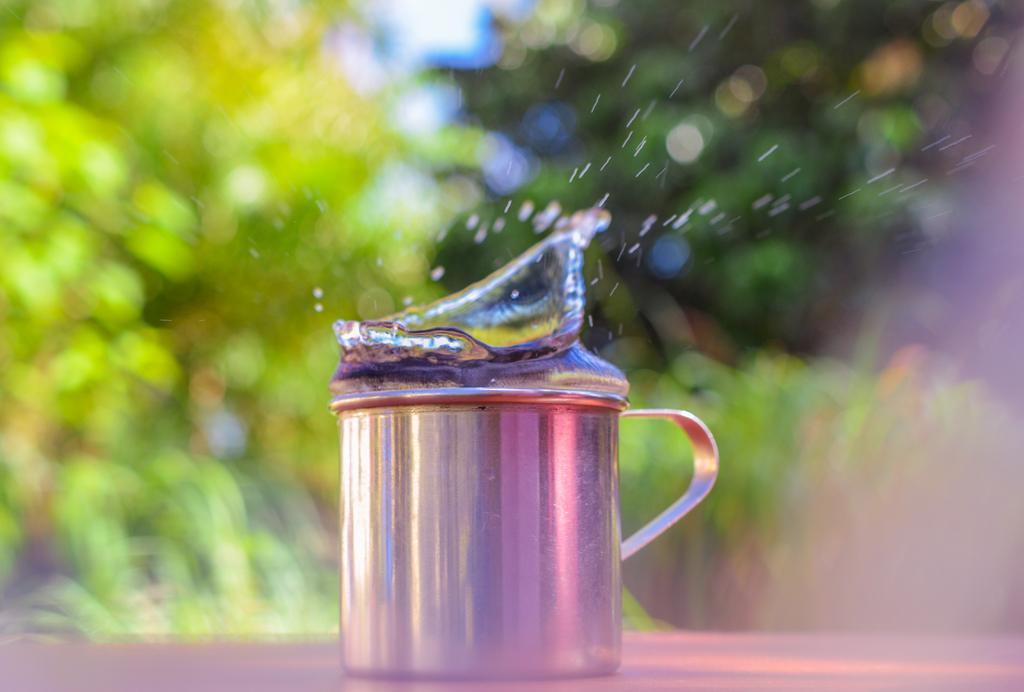In one or two sentences, can you explain what this image depicts? In this picture we can see a mug with liquid. There is a blur background with greenery. 